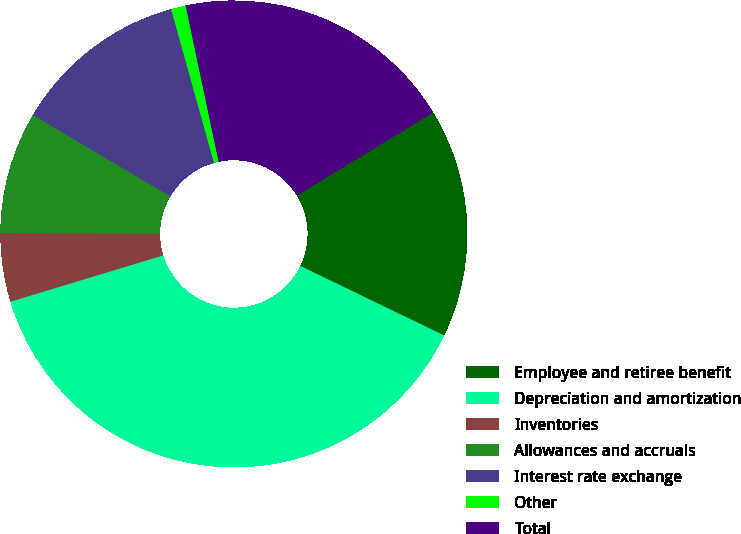<chart> <loc_0><loc_0><loc_500><loc_500><pie_chart><fcel>Employee and retiree benefit<fcel>Depreciation and amortization<fcel>Inventories<fcel>Allowances and accruals<fcel>Interest rate exchange<fcel>Other<fcel>Total<nl><fcel>15.88%<fcel>38.16%<fcel>4.74%<fcel>8.45%<fcel>12.16%<fcel>1.02%<fcel>19.59%<nl></chart> 